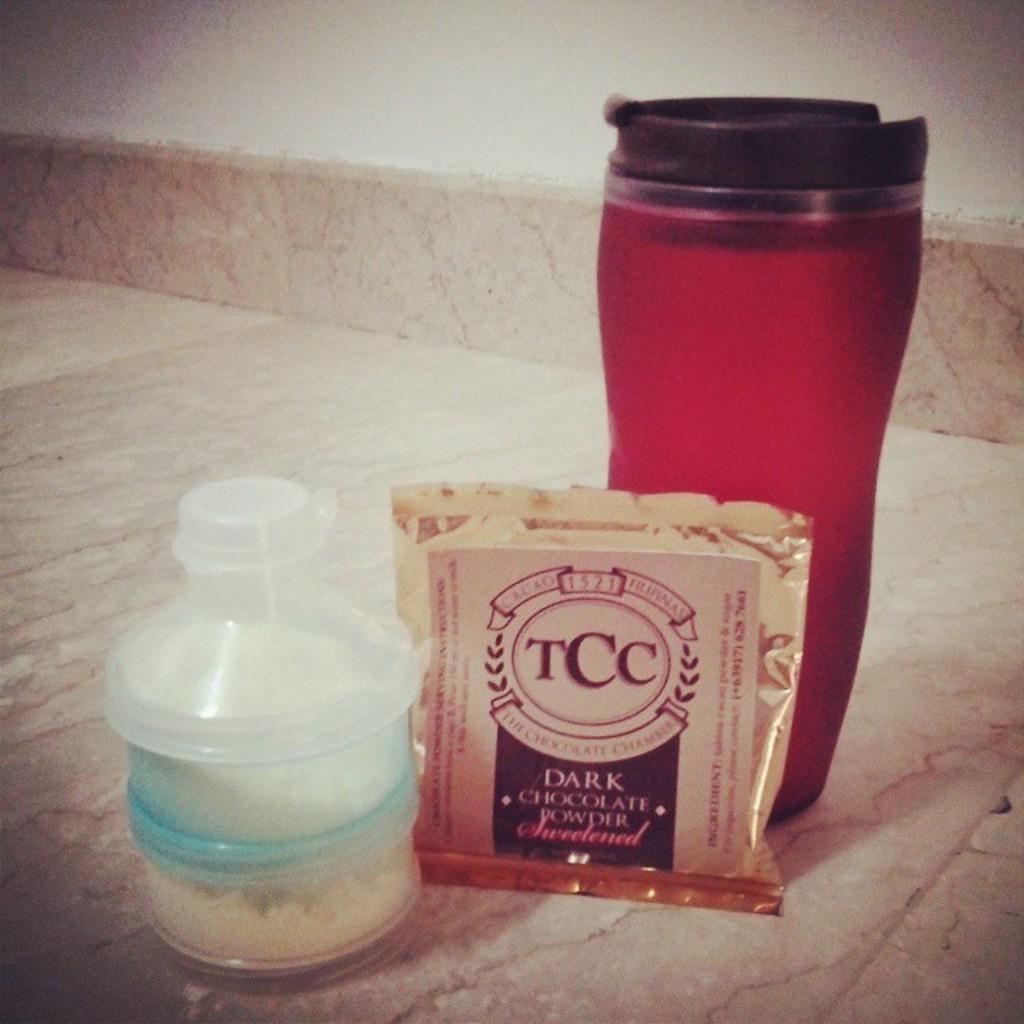Provide a one-sentence caption for the provided image. a white bottle, TCC Dark Chocolate Powder pack, and red cup on a marble top. 